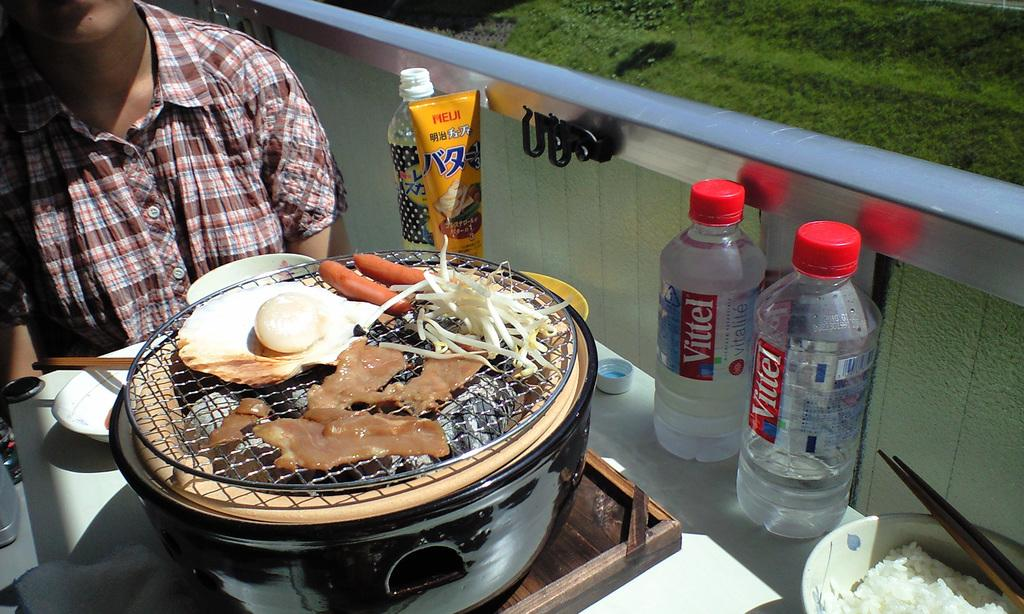<image>
Write a terse but informative summary of the picture. A person sits in front of food with two bottles of Vittel water sitting to the left. 